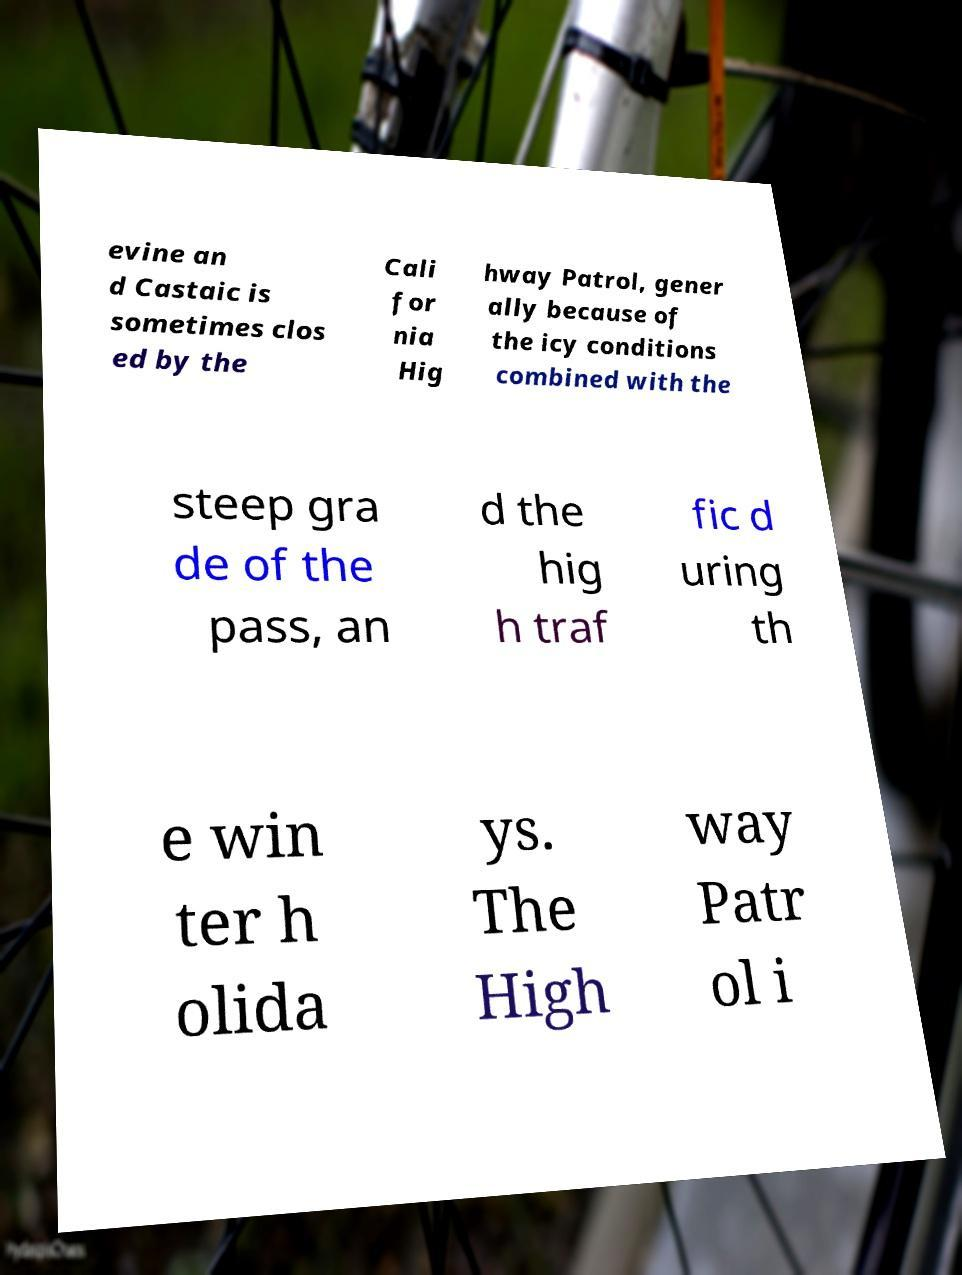Can you read and provide the text displayed in the image?This photo seems to have some interesting text. Can you extract and type it out for me? evine an d Castaic is sometimes clos ed by the Cali for nia Hig hway Patrol, gener ally because of the icy conditions combined with the steep gra de of the pass, an d the hig h traf fic d uring th e win ter h olida ys. The High way Patr ol i 